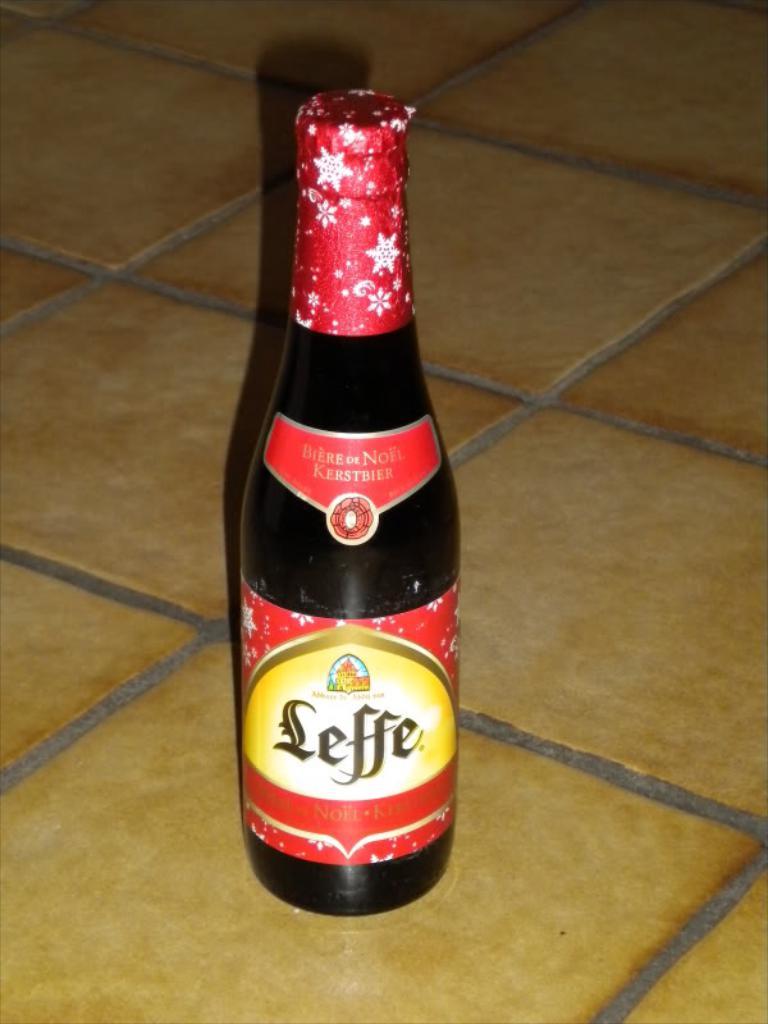What is the name of this beverage?
Your answer should be very brief. Leffe. Is this beer?
Give a very brief answer. Yes. 